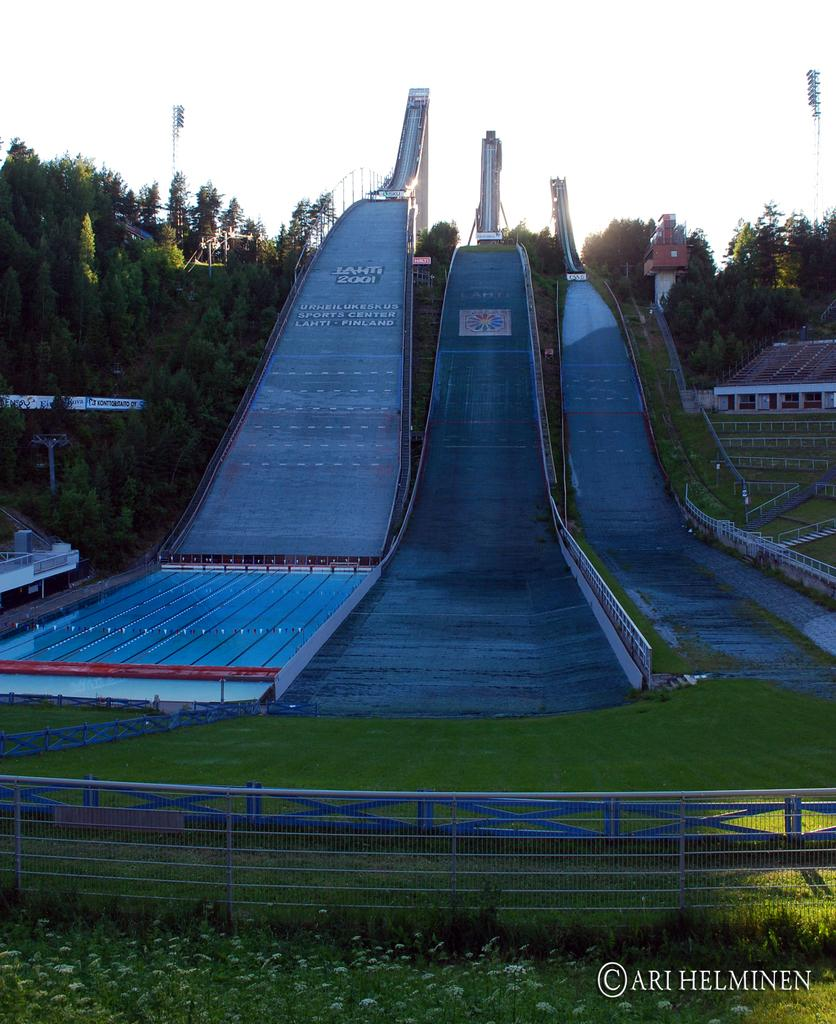What type of attractions are featured in the image? There are water rides in the image. What is located at the bottom of the image? Fencing is present at the bottom of the image. What is the ground covered with? The land is covered with grass. What can be seen in the background of the image? Trees and light poles are visible in the background of the image. What type of clover is growing in the image? There is no clover visible in the image; the land is covered with grass. How does love manifest itself in the image? Love is not a tangible object or action that can be observed in the image; it is an emotion. 